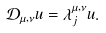<formula> <loc_0><loc_0><loc_500><loc_500>\mathcal { D } _ { \mu , \nu } u = \lambda _ { j } ^ { \mu , \nu } u .</formula> 